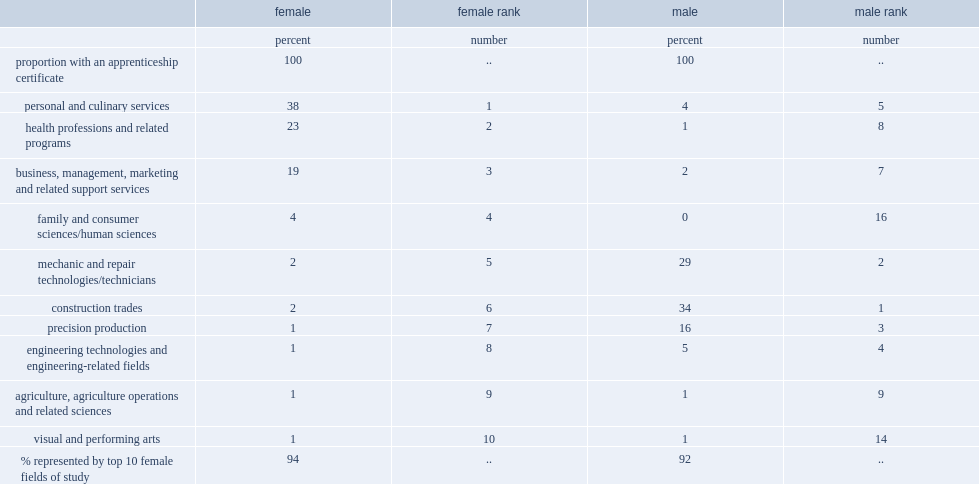What was the proportion of women aged 25 to 64 in 2011 had an apprenticeship certificate in personal and culinary services? 38.0. What was the proportion of women aged 25 to 64 in 2011 had an apprenticeship certificate in health professions and related programs? 23.0. What was the proportion of women aged 25 to 64 in 2011 had an apprenticeship certificate in business, management, marketing and related support services? 19.0. 